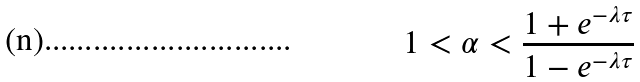<formula> <loc_0><loc_0><loc_500><loc_500>1 < \alpha < \frac { 1 + e ^ { - \lambda \tau } } { 1 - e ^ { - \lambda \tau } }</formula> 